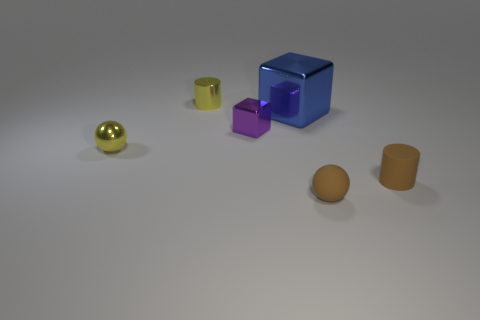Add 4 small yellow spheres. How many objects exist? 10 Subtract all cylinders. How many objects are left? 4 Subtract all tiny blue rubber cylinders. Subtract all small shiny cubes. How many objects are left? 5 Add 3 small shiny spheres. How many small shiny spheres are left? 4 Add 6 tiny gray rubber cubes. How many tiny gray rubber cubes exist? 6 Subtract 1 brown balls. How many objects are left? 5 